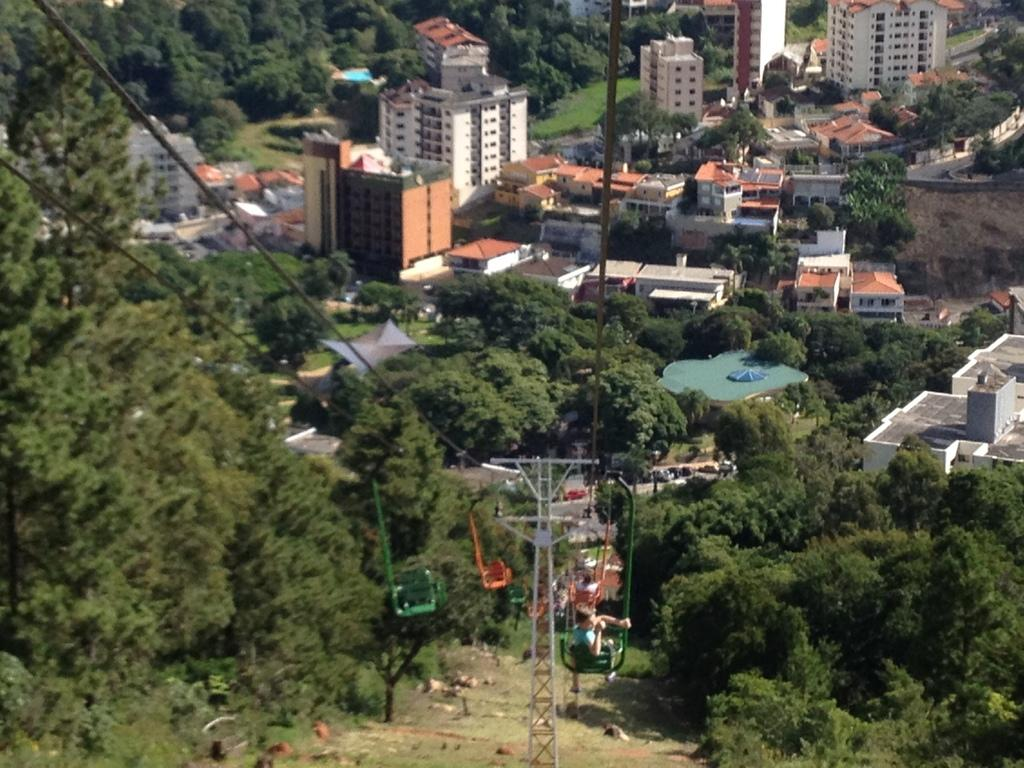What are the people in the image doing? The people are in a ropeway in the image. What can be seen supporting the ropeway? Wires and poles are visible in the image. What is visible below the ropeway? The ground is visible in the image, and trees and plants are present on the ground. What type of structures can be seen in the image? There are buildings with windows in the image. What else is visible on the ground? Roads are visible in the image. What type of rake is being used to clean the windows of the buildings in the image? There is no rake visible in the image, and no cleaning activity is taking place. How many ants can be seen crawling on the poles in the image? There are no ants present in the image. 